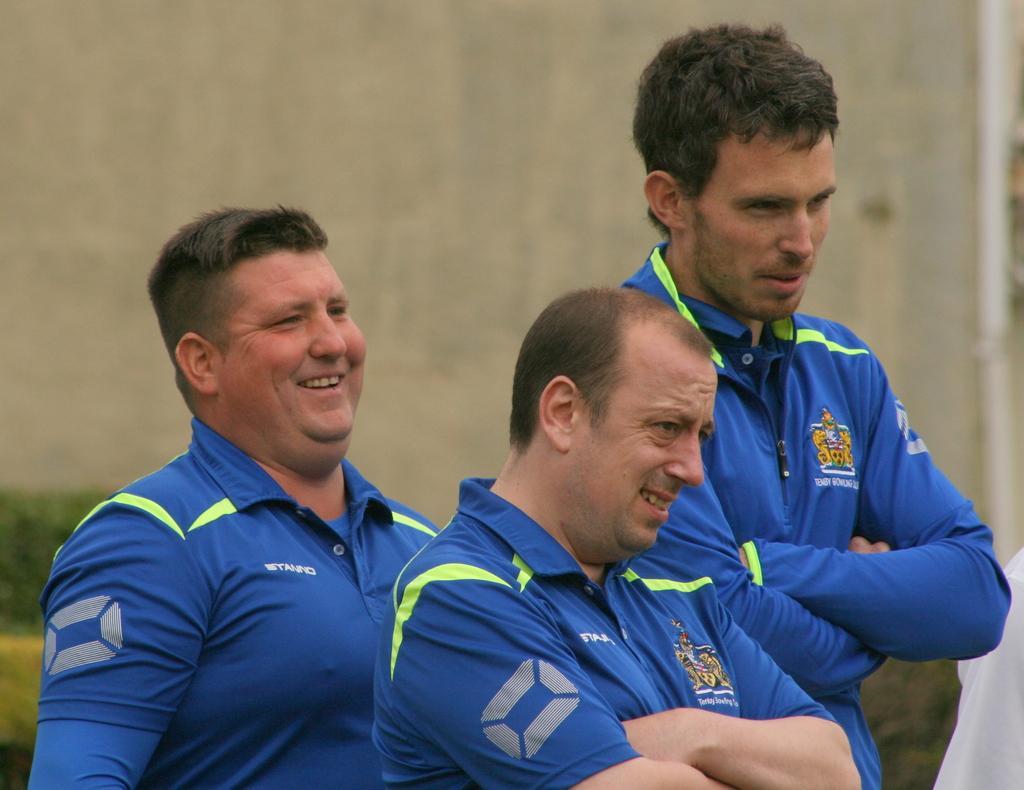Can you describe this image briefly? In this picture we can see three men smiling and in the background we can see the wall, plants and it is blurry. 